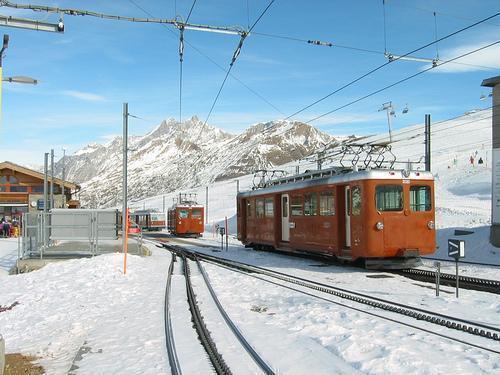What is ropeway called?
Choose the correct response and explain in the format: 'Answer: answer
Rationale: rationale.'
Options: Aerial tramway, cable way, cable car, rope way. Answer: aerial tramway.
Rationale: This tram is above the ground with cables hanging over it in sky. 